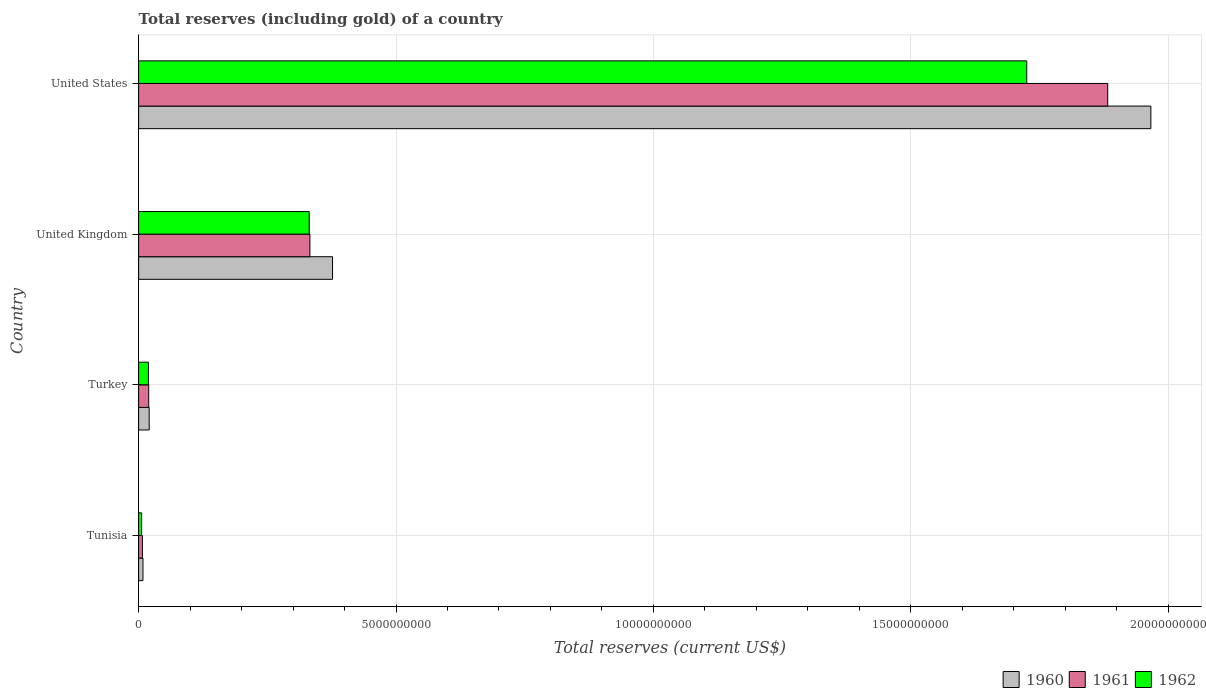How many different coloured bars are there?
Give a very brief answer. 3. What is the label of the 4th group of bars from the top?
Ensure brevity in your answer.  Tunisia. In how many cases, is the number of bars for a given country not equal to the number of legend labels?
Offer a terse response. 0. What is the total reserves (including gold) in 1962 in Tunisia?
Provide a short and direct response. 5.85e+07. Across all countries, what is the maximum total reserves (including gold) in 1961?
Give a very brief answer. 1.88e+1. Across all countries, what is the minimum total reserves (including gold) in 1960?
Your answer should be very brief. 8.45e+07. In which country was the total reserves (including gold) in 1961 maximum?
Offer a very short reply. United States. In which country was the total reserves (including gold) in 1961 minimum?
Ensure brevity in your answer.  Tunisia. What is the total total reserves (including gold) in 1960 in the graph?
Make the answer very short. 2.37e+1. What is the difference between the total reserves (including gold) in 1961 in Tunisia and that in Turkey?
Keep it short and to the point. -1.22e+08. What is the difference between the total reserves (including gold) in 1960 in United Kingdom and the total reserves (including gold) in 1961 in United States?
Make the answer very short. -1.51e+1. What is the average total reserves (including gold) in 1961 per country?
Keep it short and to the point. 5.61e+09. What is the difference between the total reserves (including gold) in 1960 and total reserves (including gold) in 1961 in Tunisia?
Provide a succinct answer. 1.11e+07. What is the ratio of the total reserves (including gold) in 1962 in Turkey to that in United Kingdom?
Offer a very short reply. 0.06. Is the total reserves (including gold) in 1962 in United Kingdom less than that in United States?
Your response must be concise. Yes. Is the difference between the total reserves (including gold) in 1960 in Turkey and United Kingdom greater than the difference between the total reserves (including gold) in 1961 in Turkey and United Kingdom?
Offer a very short reply. No. What is the difference between the highest and the second highest total reserves (including gold) in 1961?
Provide a succinct answer. 1.55e+1. What is the difference between the highest and the lowest total reserves (including gold) in 1961?
Give a very brief answer. 1.88e+1. What does the 3rd bar from the top in Tunisia represents?
Your response must be concise. 1960. How many bars are there?
Make the answer very short. 12. How many countries are there in the graph?
Keep it short and to the point. 4. What is the difference between two consecutive major ticks on the X-axis?
Your answer should be compact. 5.00e+09. How are the legend labels stacked?
Provide a succinct answer. Horizontal. What is the title of the graph?
Ensure brevity in your answer.  Total reserves (including gold) of a country. Does "1998" appear as one of the legend labels in the graph?
Give a very brief answer. No. What is the label or title of the X-axis?
Offer a terse response. Total reserves (current US$). What is the Total reserves (current US$) in 1960 in Tunisia?
Your answer should be compact. 8.45e+07. What is the Total reserves (current US$) in 1961 in Tunisia?
Your answer should be very brief. 7.33e+07. What is the Total reserves (current US$) in 1962 in Tunisia?
Provide a succinct answer. 5.85e+07. What is the Total reserves (current US$) in 1960 in Turkey?
Make the answer very short. 2.05e+08. What is the Total reserves (current US$) of 1961 in Turkey?
Your response must be concise. 1.96e+08. What is the Total reserves (current US$) in 1962 in Turkey?
Your response must be concise. 1.90e+08. What is the Total reserves (current US$) of 1960 in United Kingdom?
Keep it short and to the point. 3.77e+09. What is the Total reserves (current US$) of 1961 in United Kingdom?
Give a very brief answer. 3.33e+09. What is the Total reserves (current US$) in 1962 in United Kingdom?
Offer a terse response. 3.31e+09. What is the Total reserves (current US$) of 1960 in United States?
Give a very brief answer. 1.97e+1. What is the Total reserves (current US$) in 1961 in United States?
Provide a succinct answer. 1.88e+1. What is the Total reserves (current US$) in 1962 in United States?
Make the answer very short. 1.73e+1. Across all countries, what is the maximum Total reserves (current US$) of 1960?
Offer a very short reply. 1.97e+1. Across all countries, what is the maximum Total reserves (current US$) in 1961?
Your answer should be very brief. 1.88e+1. Across all countries, what is the maximum Total reserves (current US$) in 1962?
Provide a short and direct response. 1.73e+1. Across all countries, what is the minimum Total reserves (current US$) of 1960?
Your response must be concise. 8.45e+07. Across all countries, what is the minimum Total reserves (current US$) in 1961?
Your answer should be very brief. 7.33e+07. Across all countries, what is the minimum Total reserves (current US$) in 1962?
Your response must be concise. 5.85e+07. What is the total Total reserves (current US$) in 1960 in the graph?
Provide a short and direct response. 2.37e+1. What is the total Total reserves (current US$) in 1961 in the graph?
Keep it short and to the point. 2.24e+1. What is the total Total reserves (current US$) in 1962 in the graph?
Offer a very short reply. 2.08e+1. What is the difference between the Total reserves (current US$) of 1960 in Tunisia and that in Turkey?
Keep it short and to the point. -1.21e+08. What is the difference between the Total reserves (current US$) of 1961 in Tunisia and that in Turkey?
Provide a succinct answer. -1.22e+08. What is the difference between the Total reserves (current US$) in 1962 in Tunisia and that in Turkey?
Your answer should be compact. -1.32e+08. What is the difference between the Total reserves (current US$) of 1960 in Tunisia and that in United Kingdom?
Make the answer very short. -3.68e+09. What is the difference between the Total reserves (current US$) in 1961 in Tunisia and that in United Kingdom?
Offer a very short reply. -3.25e+09. What is the difference between the Total reserves (current US$) of 1962 in Tunisia and that in United Kingdom?
Your answer should be compact. -3.25e+09. What is the difference between the Total reserves (current US$) of 1960 in Tunisia and that in United States?
Offer a very short reply. -1.96e+1. What is the difference between the Total reserves (current US$) of 1961 in Tunisia and that in United States?
Make the answer very short. -1.88e+1. What is the difference between the Total reserves (current US$) in 1962 in Tunisia and that in United States?
Provide a succinct answer. -1.72e+1. What is the difference between the Total reserves (current US$) of 1960 in Turkey and that in United Kingdom?
Provide a succinct answer. -3.56e+09. What is the difference between the Total reserves (current US$) in 1961 in Turkey and that in United Kingdom?
Provide a short and direct response. -3.13e+09. What is the difference between the Total reserves (current US$) in 1962 in Turkey and that in United Kingdom?
Your answer should be very brief. -3.12e+09. What is the difference between the Total reserves (current US$) in 1960 in Turkey and that in United States?
Offer a very short reply. -1.95e+1. What is the difference between the Total reserves (current US$) of 1961 in Turkey and that in United States?
Provide a short and direct response. -1.86e+1. What is the difference between the Total reserves (current US$) in 1962 in Turkey and that in United States?
Your response must be concise. -1.71e+1. What is the difference between the Total reserves (current US$) of 1960 in United Kingdom and that in United States?
Make the answer very short. -1.59e+1. What is the difference between the Total reserves (current US$) in 1961 in United Kingdom and that in United States?
Give a very brief answer. -1.55e+1. What is the difference between the Total reserves (current US$) in 1962 in United Kingdom and that in United States?
Ensure brevity in your answer.  -1.39e+1. What is the difference between the Total reserves (current US$) in 1960 in Tunisia and the Total reserves (current US$) in 1961 in Turkey?
Give a very brief answer. -1.11e+08. What is the difference between the Total reserves (current US$) of 1960 in Tunisia and the Total reserves (current US$) of 1962 in Turkey?
Offer a very short reply. -1.06e+08. What is the difference between the Total reserves (current US$) in 1961 in Tunisia and the Total reserves (current US$) in 1962 in Turkey?
Your answer should be compact. -1.17e+08. What is the difference between the Total reserves (current US$) in 1960 in Tunisia and the Total reserves (current US$) in 1961 in United Kingdom?
Offer a very short reply. -3.24e+09. What is the difference between the Total reserves (current US$) of 1960 in Tunisia and the Total reserves (current US$) of 1962 in United Kingdom?
Your response must be concise. -3.23e+09. What is the difference between the Total reserves (current US$) in 1961 in Tunisia and the Total reserves (current US$) in 1962 in United Kingdom?
Provide a short and direct response. -3.24e+09. What is the difference between the Total reserves (current US$) in 1960 in Tunisia and the Total reserves (current US$) in 1961 in United States?
Offer a very short reply. -1.87e+1. What is the difference between the Total reserves (current US$) of 1960 in Tunisia and the Total reserves (current US$) of 1962 in United States?
Make the answer very short. -1.72e+1. What is the difference between the Total reserves (current US$) in 1961 in Tunisia and the Total reserves (current US$) in 1962 in United States?
Keep it short and to the point. -1.72e+1. What is the difference between the Total reserves (current US$) in 1960 in Turkey and the Total reserves (current US$) in 1961 in United Kingdom?
Provide a succinct answer. -3.12e+09. What is the difference between the Total reserves (current US$) of 1960 in Turkey and the Total reserves (current US$) of 1962 in United Kingdom?
Offer a very short reply. -3.11e+09. What is the difference between the Total reserves (current US$) of 1961 in Turkey and the Total reserves (current US$) of 1962 in United Kingdom?
Your answer should be compact. -3.12e+09. What is the difference between the Total reserves (current US$) of 1960 in Turkey and the Total reserves (current US$) of 1961 in United States?
Your answer should be compact. -1.86e+1. What is the difference between the Total reserves (current US$) in 1960 in Turkey and the Total reserves (current US$) in 1962 in United States?
Your response must be concise. -1.70e+1. What is the difference between the Total reserves (current US$) in 1961 in Turkey and the Total reserves (current US$) in 1962 in United States?
Your response must be concise. -1.71e+1. What is the difference between the Total reserves (current US$) in 1960 in United Kingdom and the Total reserves (current US$) in 1961 in United States?
Provide a succinct answer. -1.51e+1. What is the difference between the Total reserves (current US$) in 1960 in United Kingdom and the Total reserves (current US$) in 1962 in United States?
Your response must be concise. -1.35e+1. What is the difference between the Total reserves (current US$) of 1961 in United Kingdom and the Total reserves (current US$) of 1962 in United States?
Your answer should be compact. -1.39e+1. What is the average Total reserves (current US$) of 1960 per country?
Provide a short and direct response. 5.93e+09. What is the average Total reserves (current US$) in 1961 per country?
Give a very brief answer. 5.61e+09. What is the average Total reserves (current US$) of 1962 per country?
Your answer should be compact. 5.20e+09. What is the difference between the Total reserves (current US$) in 1960 and Total reserves (current US$) in 1961 in Tunisia?
Provide a short and direct response. 1.11e+07. What is the difference between the Total reserves (current US$) in 1960 and Total reserves (current US$) in 1962 in Tunisia?
Offer a terse response. 2.59e+07. What is the difference between the Total reserves (current US$) in 1961 and Total reserves (current US$) in 1962 in Tunisia?
Your response must be concise. 1.48e+07. What is the difference between the Total reserves (current US$) in 1960 and Total reserves (current US$) in 1961 in Turkey?
Offer a very short reply. 9.56e+06. What is the difference between the Total reserves (current US$) in 1960 and Total reserves (current US$) in 1962 in Turkey?
Ensure brevity in your answer.  1.48e+07. What is the difference between the Total reserves (current US$) of 1961 and Total reserves (current US$) of 1962 in Turkey?
Keep it short and to the point. 5.29e+06. What is the difference between the Total reserves (current US$) of 1960 and Total reserves (current US$) of 1961 in United Kingdom?
Your response must be concise. 4.39e+08. What is the difference between the Total reserves (current US$) of 1960 and Total reserves (current US$) of 1962 in United Kingdom?
Offer a terse response. 4.54e+08. What is the difference between the Total reserves (current US$) of 1961 and Total reserves (current US$) of 1962 in United Kingdom?
Keep it short and to the point. 1.46e+07. What is the difference between the Total reserves (current US$) of 1960 and Total reserves (current US$) of 1961 in United States?
Keep it short and to the point. 8.39e+08. What is the difference between the Total reserves (current US$) in 1960 and Total reserves (current US$) in 1962 in United States?
Ensure brevity in your answer.  2.41e+09. What is the difference between the Total reserves (current US$) of 1961 and Total reserves (current US$) of 1962 in United States?
Your answer should be compact. 1.57e+09. What is the ratio of the Total reserves (current US$) in 1960 in Tunisia to that in Turkey?
Ensure brevity in your answer.  0.41. What is the ratio of the Total reserves (current US$) in 1961 in Tunisia to that in Turkey?
Your response must be concise. 0.37. What is the ratio of the Total reserves (current US$) in 1962 in Tunisia to that in Turkey?
Your response must be concise. 0.31. What is the ratio of the Total reserves (current US$) in 1960 in Tunisia to that in United Kingdom?
Offer a terse response. 0.02. What is the ratio of the Total reserves (current US$) in 1961 in Tunisia to that in United Kingdom?
Offer a very short reply. 0.02. What is the ratio of the Total reserves (current US$) in 1962 in Tunisia to that in United Kingdom?
Offer a terse response. 0.02. What is the ratio of the Total reserves (current US$) of 1960 in Tunisia to that in United States?
Ensure brevity in your answer.  0. What is the ratio of the Total reserves (current US$) in 1961 in Tunisia to that in United States?
Your answer should be very brief. 0. What is the ratio of the Total reserves (current US$) in 1962 in Tunisia to that in United States?
Offer a very short reply. 0. What is the ratio of the Total reserves (current US$) of 1960 in Turkey to that in United Kingdom?
Keep it short and to the point. 0.05. What is the ratio of the Total reserves (current US$) of 1961 in Turkey to that in United Kingdom?
Your response must be concise. 0.06. What is the ratio of the Total reserves (current US$) in 1962 in Turkey to that in United Kingdom?
Give a very brief answer. 0.06. What is the ratio of the Total reserves (current US$) in 1960 in Turkey to that in United States?
Your answer should be very brief. 0.01. What is the ratio of the Total reserves (current US$) in 1961 in Turkey to that in United States?
Make the answer very short. 0.01. What is the ratio of the Total reserves (current US$) of 1962 in Turkey to that in United States?
Give a very brief answer. 0.01. What is the ratio of the Total reserves (current US$) in 1960 in United Kingdom to that in United States?
Your answer should be very brief. 0.19. What is the ratio of the Total reserves (current US$) in 1961 in United Kingdom to that in United States?
Ensure brevity in your answer.  0.18. What is the ratio of the Total reserves (current US$) of 1962 in United Kingdom to that in United States?
Ensure brevity in your answer.  0.19. What is the difference between the highest and the second highest Total reserves (current US$) in 1960?
Your answer should be very brief. 1.59e+1. What is the difference between the highest and the second highest Total reserves (current US$) of 1961?
Ensure brevity in your answer.  1.55e+1. What is the difference between the highest and the second highest Total reserves (current US$) in 1962?
Provide a succinct answer. 1.39e+1. What is the difference between the highest and the lowest Total reserves (current US$) in 1960?
Provide a succinct answer. 1.96e+1. What is the difference between the highest and the lowest Total reserves (current US$) of 1961?
Your answer should be compact. 1.88e+1. What is the difference between the highest and the lowest Total reserves (current US$) in 1962?
Provide a short and direct response. 1.72e+1. 